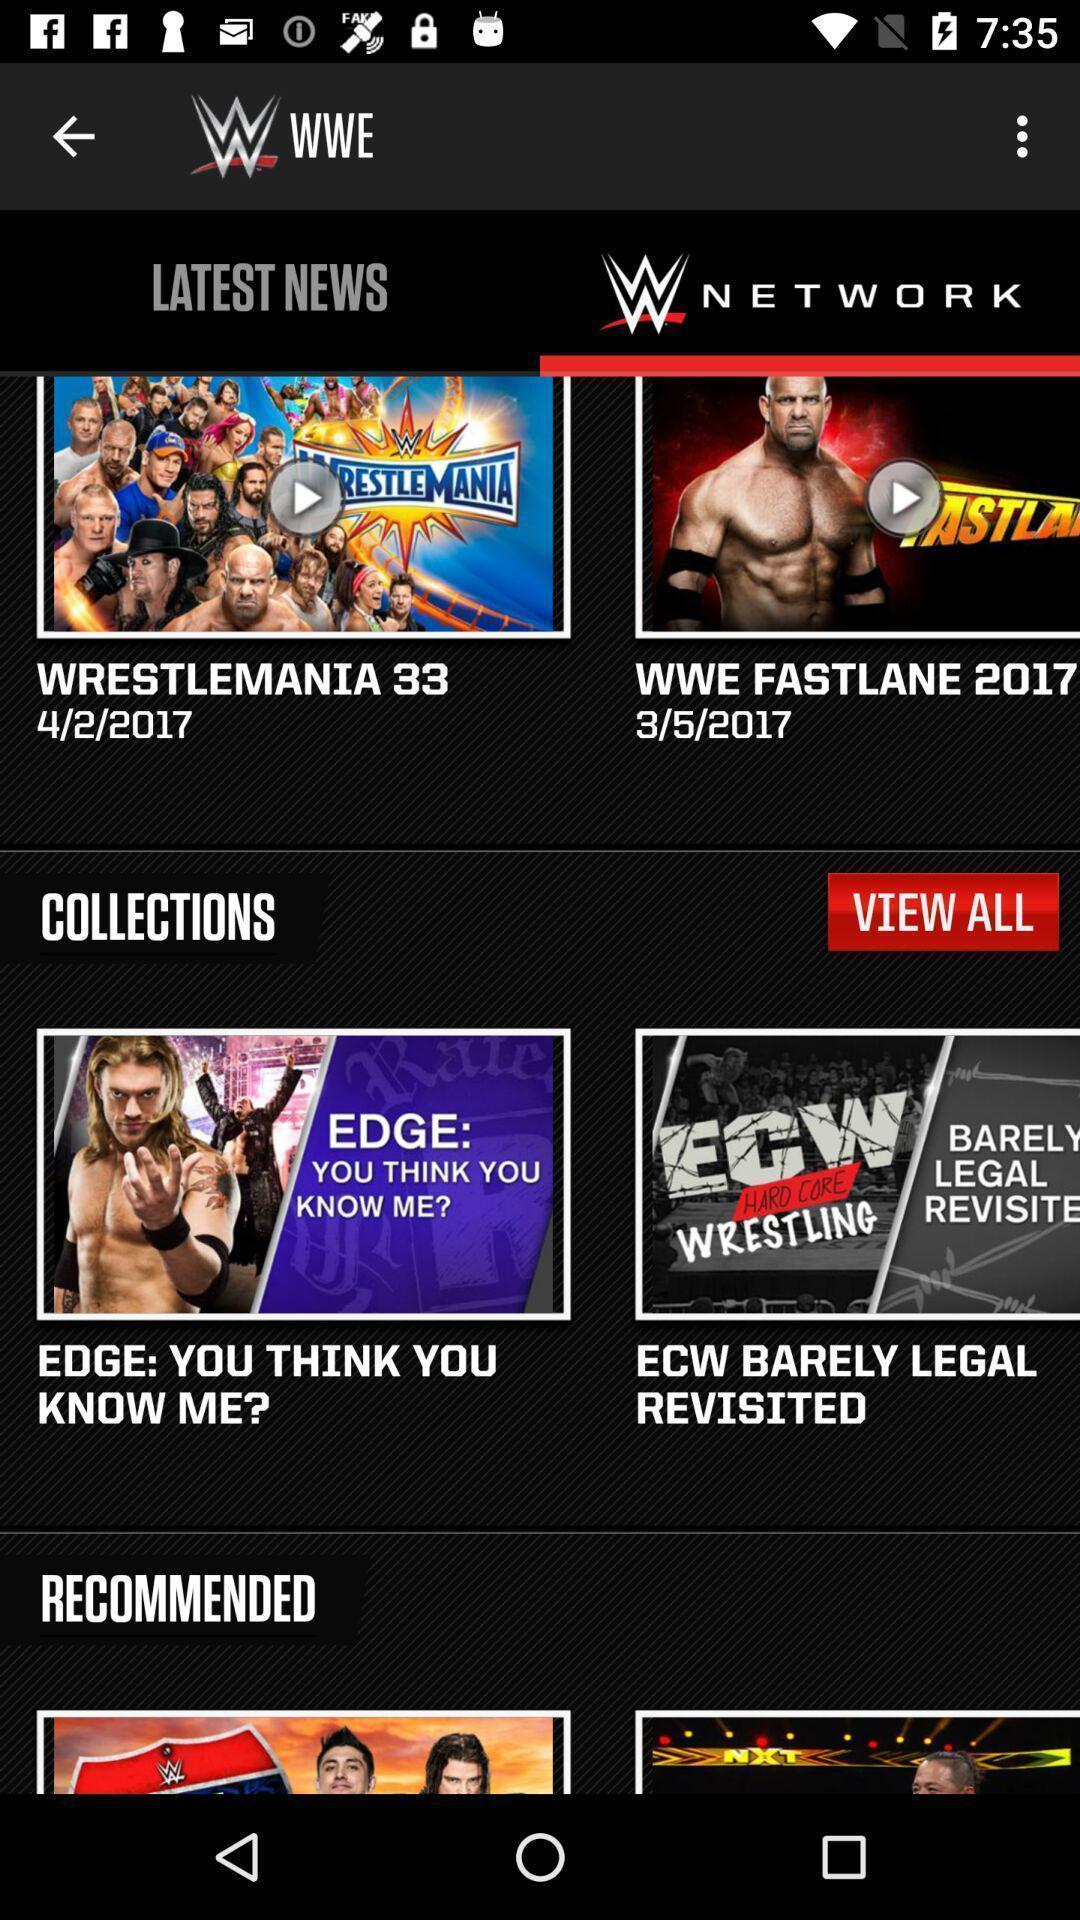Provide a detailed account of this screenshot. Screen displaying multiple videos and articles in a sports application. 